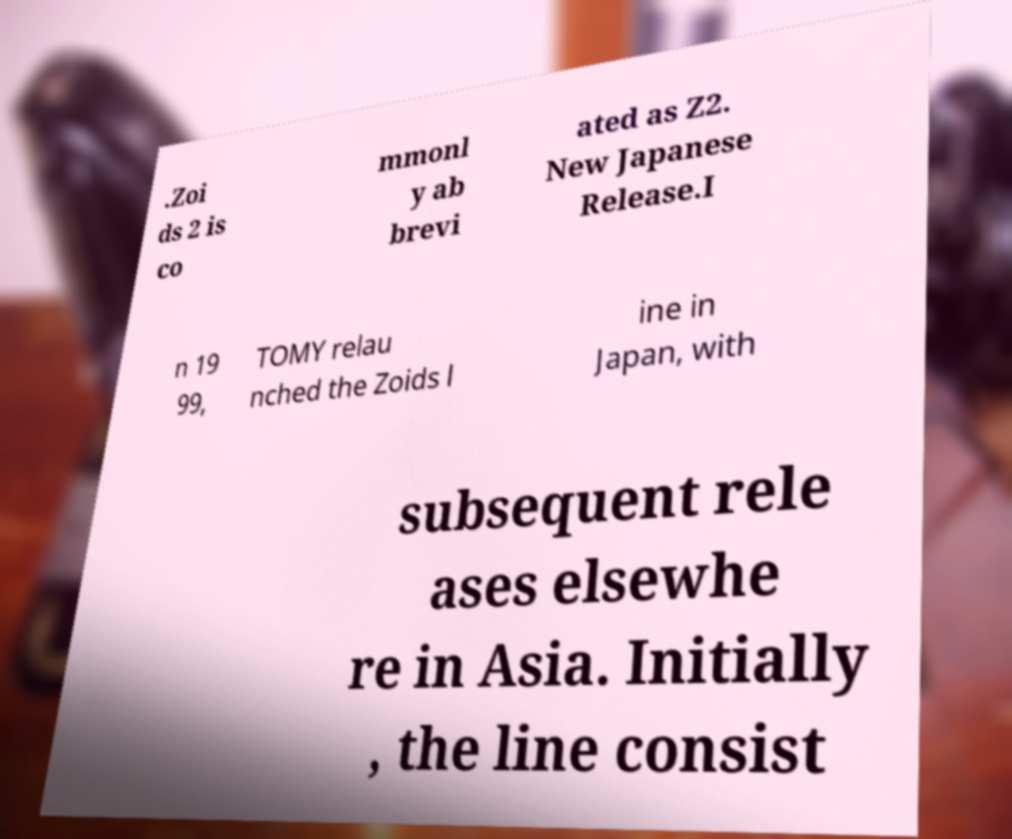Can you accurately transcribe the text from the provided image for me? .Zoi ds 2 is co mmonl y ab brevi ated as Z2. New Japanese Release.I n 19 99, TOMY relau nched the Zoids l ine in Japan, with subsequent rele ases elsewhe re in Asia. Initially , the line consist 